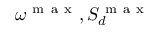Convert formula to latex. <formula><loc_0><loc_0><loc_500><loc_500>\omega ^ { m a x } , S _ { d } ^ { m a x }</formula> 